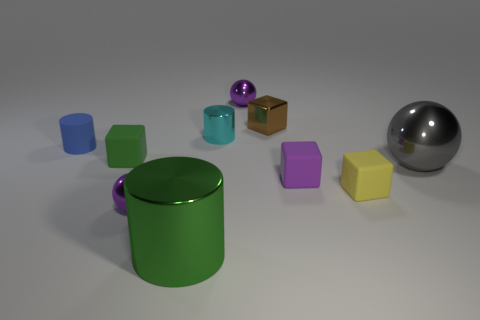How many other things are made of the same material as the tiny cyan cylinder?
Provide a succinct answer. 5. There is a green cylinder that is the same size as the gray sphere; what is it made of?
Ensure brevity in your answer.  Metal. Is the color of the big object that is behind the green metal object the same as the shiny thing on the left side of the large green metal thing?
Your response must be concise. No. Are there any big purple matte objects that have the same shape as the blue thing?
Your answer should be very brief. No. There is a blue object that is the same size as the cyan metallic object; what is its shape?
Give a very brief answer. Cylinder. What number of tiny rubber cubes have the same color as the big cylinder?
Your answer should be very brief. 1. How big is the purple object that is behind the small cyan metal cylinder?
Your response must be concise. Small. What number of gray things have the same size as the blue object?
Offer a terse response. 0. What is the color of the small cylinder that is made of the same material as the yellow thing?
Keep it short and to the point. Blue. Are there fewer shiny cubes in front of the tiny metal block than small blocks?
Make the answer very short. Yes. 